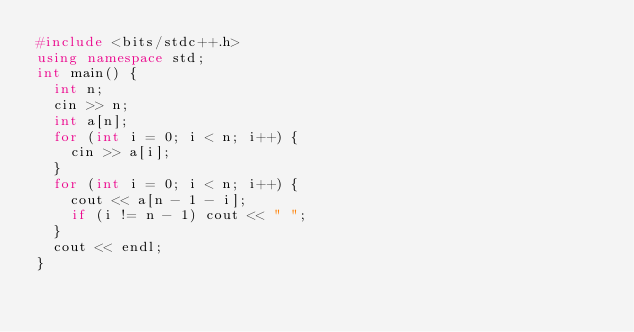Convert code to text. <code><loc_0><loc_0><loc_500><loc_500><_C++_>#include <bits/stdc++.h>
using namespace std;
int main() {
  int n;
  cin >> n;
  int a[n];
  for (int i = 0; i < n; i++) {
    cin >> a[i];
  }
  for (int i = 0; i < n; i++) {
    cout << a[n - 1 - i];
    if (i != n - 1) cout << " ";
  }
  cout << endl;
}
</code> 